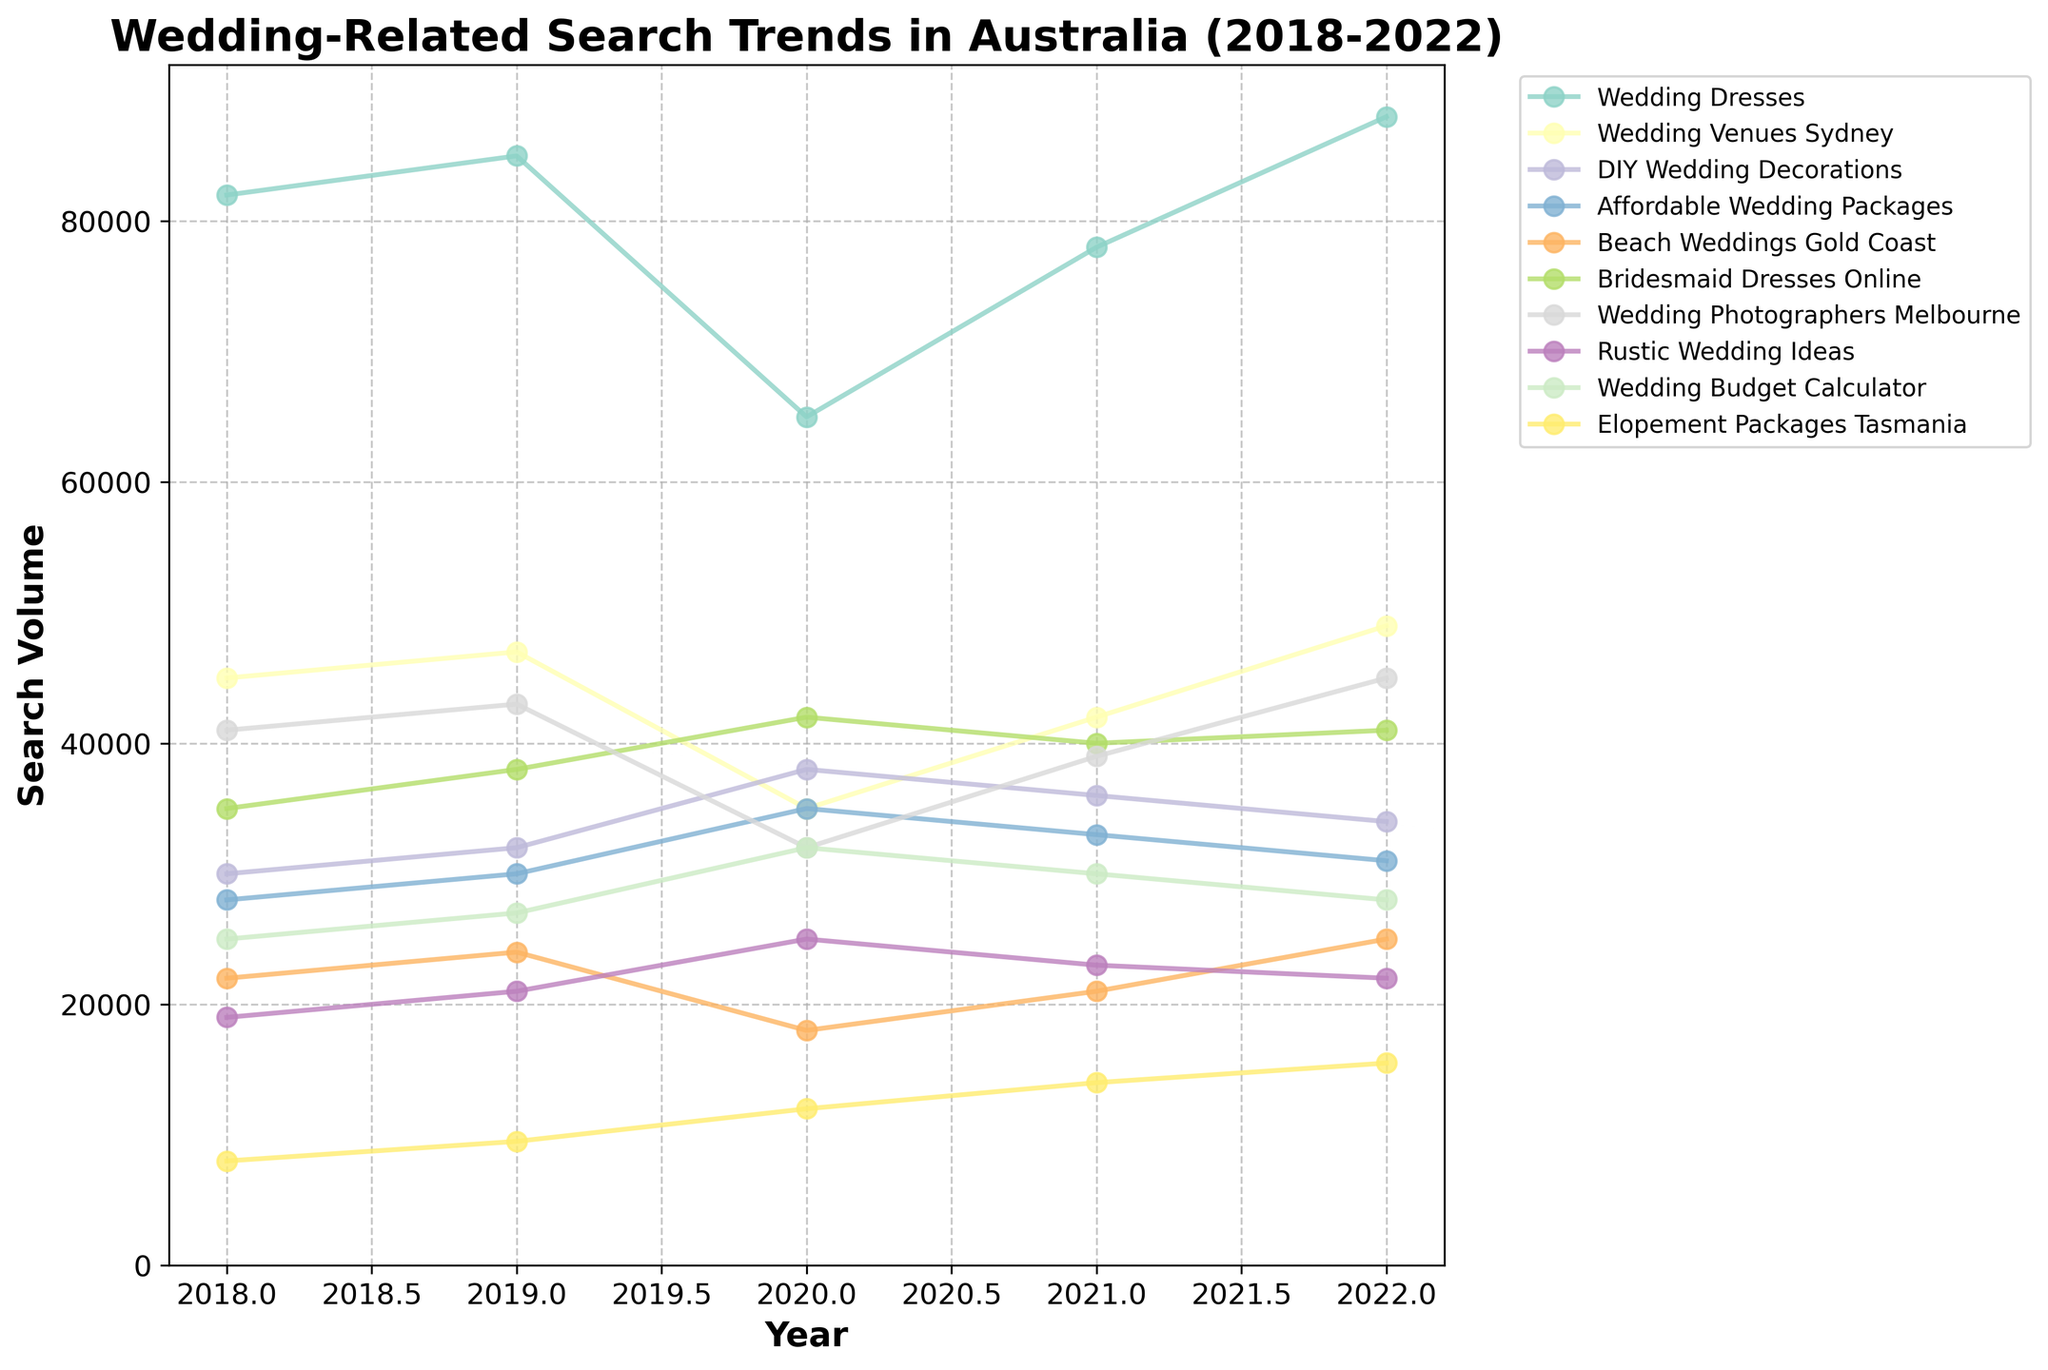What was the trend for "Wedding Dresses" search volume from 2018 to 2022? The search volume for "Wedding Dresses" started at 82,000 in 2018, increased slightly to 85,000 in 2019, dropped to 65,000 in 2020, rose again to 78,000 in 2021, and peaked at 88,000 in 2022.
Answer: Gradual increase with a dip in 2020 Which keyword had the highest search volume in 2022? Observing the data for 2022, "Wedding Dresses" had the highest search volume with 88,000 searches.
Answer: Wedding Dresses How did the search volume for "Beach Weddings Gold Coast" change between 2018 and 2022? The search volume for "Beach Weddings Gold Coast" was 22,000 in 2018, increased slightly to 24,000 in 2019, dropped to 18,000 in 2020, then rose to 21,000 in 2021, and reached 25,000 in 2022.
Answer: Fluctuated but ended higher Which keyword showed the most significant drop in search volume in 2020 compared to 2019? Comparing the search volumes between 2019 and 2020, "Wedding Venues Sydney" showed the most significant drop from 47,000 to 35,000, a decline of 12,000.
Answer: Wedding Venues Sydney What is the average search volume for "DIY Wedding Decorations" over the 5 years? Adding the values from 2018 to 2022: (30,000 + 32,000 + 38,000 + 36,000 + 34,000) = 170,000. Dividing by 5 gives 34,000.
Answer: 34,000 Which keyword had the least fluctuating trend in search volume over the 5 years? Observing the trends, "Affordable Wedding Packages" had relatively small fluctuations each year: 28,000 (2018), 30,000 (2019), 35,000 (2020), 33,000 (2021), and 31,000 (2022).
Answer: Affordable Wedding Packages How did "Wedding Budget Calculator" search volume change from 2018 to 2022, and what could this indicate? The search volume increased from 25,000 in 2018 to 32,000 in 2020, then decreased slightly to 30,000 in 2021 and 28,000 in 2022. This fluctuating trend might indicate varying interest in wedding budgeting resources over the years.
Answer: Fluctuated, indicating varying interest Which two keywords had the closest search volumes in 2021? Looking at the 2021 data, "Bridesmaid Dresses Online" (40,000) and "Wedding Photographers Melbourne" (39,000) had the closest search volumes.
Answer: Bridesmaid Dresses Online and Wedding Photographers Melbourne What was the highest search volume recorded for "Elopement Packages Tasmania", and in what year did it occur? The highest search volume for "Elopement Packages Tasmania" was 15,500 in 2022.
Answer: 15,500 in 2022 How did the search volumes for "Rustic Wedding Ideas" change from 2018 to 2022? The search volume for "Rustic Wedding Ideas" was 19,000 in 2018, increased to 21,000 in 2019, jumped to 25,000 in 2020, then dropped slightly to 23,000 in 2021, and further down to 22,000 in 2022.
Answer: Increased initially, then decreased 